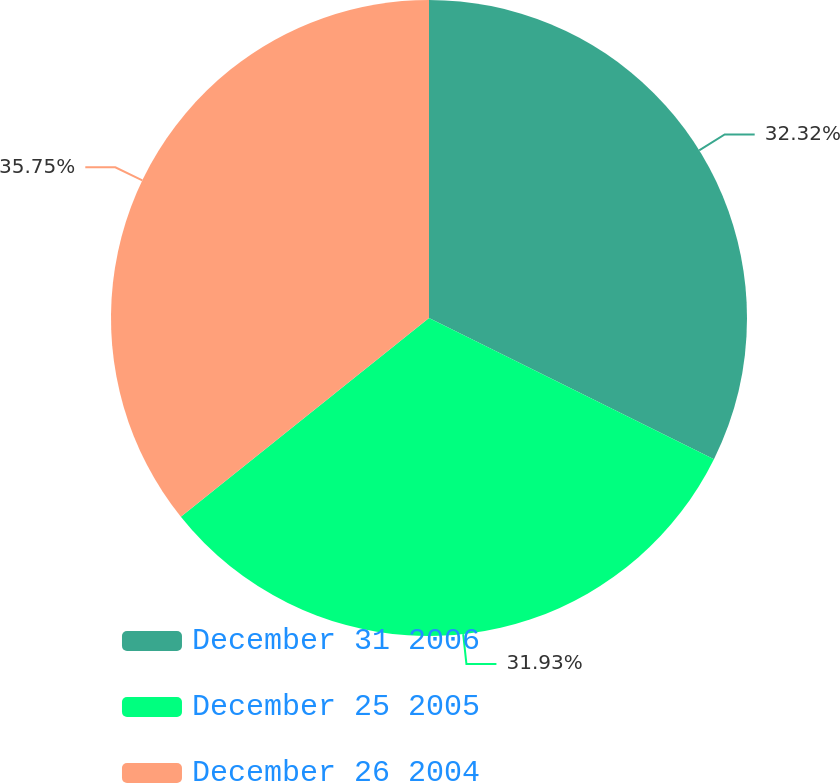<chart> <loc_0><loc_0><loc_500><loc_500><pie_chart><fcel>December 31 2006<fcel>December 25 2005<fcel>December 26 2004<nl><fcel>32.32%<fcel>31.93%<fcel>35.75%<nl></chart> 